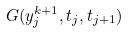<formula> <loc_0><loc_0><loc_500><loc_500>G ( y _ { j } ^ { k + 1 } , t _ { j } , t _ { j + 1 } )</formula> 